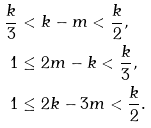<formula> <loc_0><loc_0><loc_500><loc_500>\frac { k } { 3 } < & \ k - m < \frac { k } { 2 } , \\ 1 \leq & \ 2 m - k < \frac { k } { 3 } , \\ 1 \leq & \ 2 k - 3 m < \frac { k } { 2 } .</formula> 